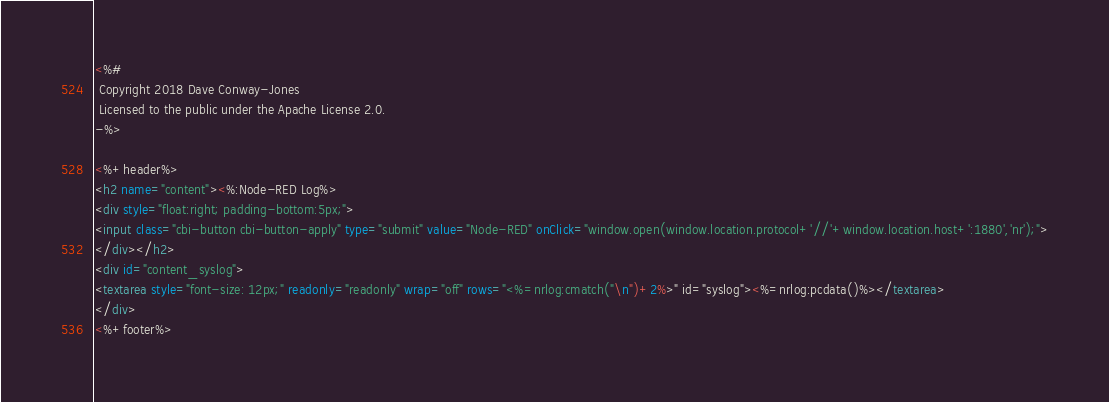Convert code to text. <code><loc_0><loc_0><loc_500><loc_500><_HTML_><%#
 Copyright 2018 Dave Conway-Jones
 Licensed to the public under the Apache License 2.0.
-%>

<%+header%>
<h2 name="content"><%:Node-RED Log%>
<div style="float:right; padding-bottom:5px;">
<input class="cbi-button cbi-button-apply" type="submit" value="Node-RED" onClick="window.open(window.location.protocol+'//'+window.location.host+':1880','nr');">
</div></h2>
<div id="content_syslog">
<textarea style="font-size: 12px;" readonly="readonly" wrap="off" rows="<%=nrlog:cmatch("\n")+2%>" id="syslog"><%=nrlog:pcdata()%></textarea>
</div>
<%+footer%>
</code> 